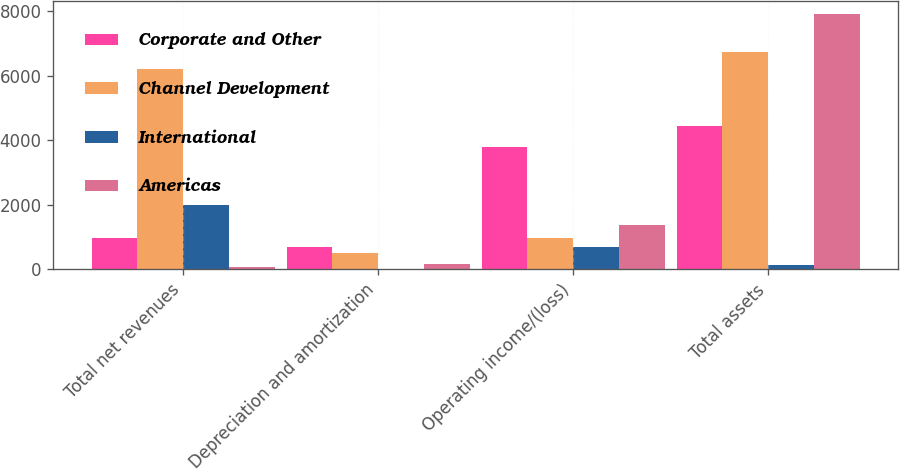<chart> <loc_0><loc_0><loc_500><loc_500><stacked_bar_chart><ecel><fcel>Total net revenues<fcel>Depreciation and amortization<fcel>Operating income/(loss)<fcel>Total assets<nl><fcel>Corporate and Other<fcel>964.7<fcel>696.1<fcel>3782.8<fcel>4446.7<nl><fcel>Channel Development<fcel>6190.7<fcel>511.5<fcel>964.7<fcel>6724.6<nl><fcel>International<fcel>1992.6<fcel>13<fcel>697.5<fcel>132.2<nl><fcel>Americas<fcel>66.3<fcel>156.7<fcel>1367.1<fcel>7916.1<nl></chart> 